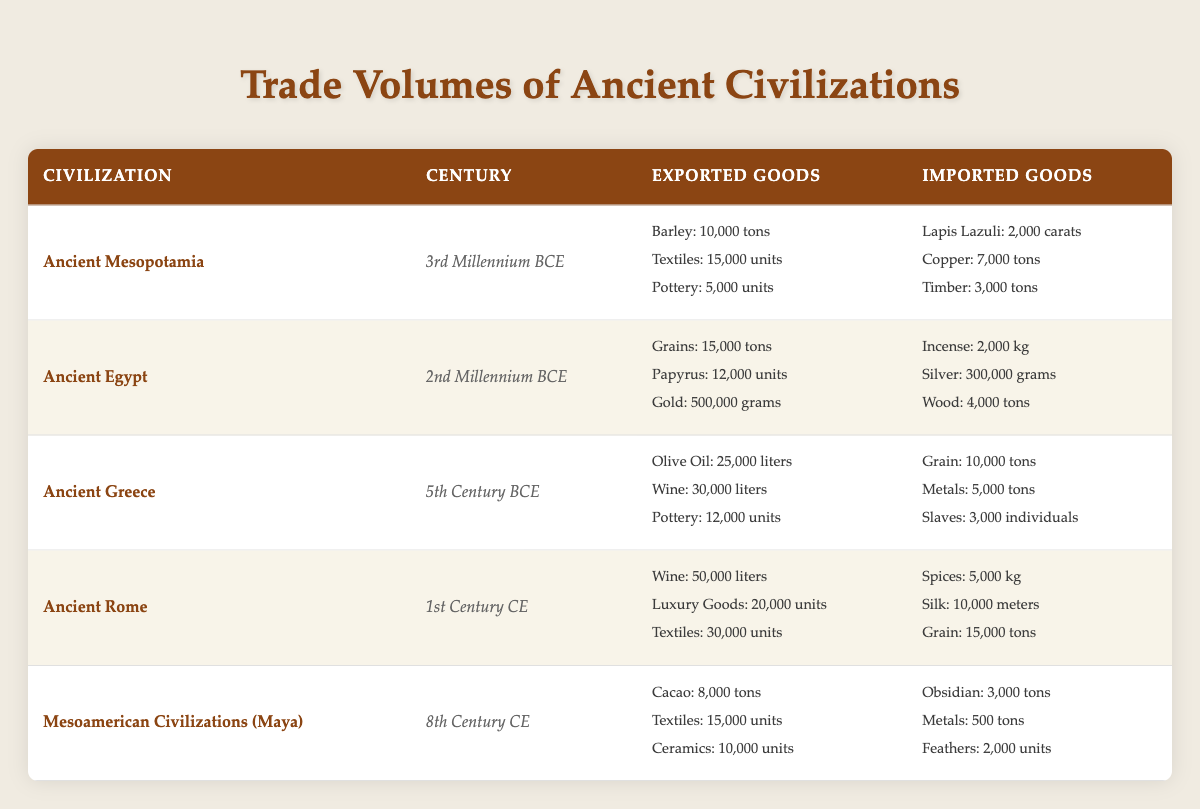What civilization exported the most quantities of textiles? According to the table, Ancient Rome exported 30,000 units of textiles, which is the highest compared to other civilizations listed.
Answer: Ancient Rome How many tons of barley did Ancient Mesopotamia export? The table states that Ancient Mesopotamia exported 10,000 tons of barley as per the recorded data.
Answer: 10,000 tons Did Ancient Egypt import more incense than silver? The table shows that Ancient Egypt imported 2,000 kg of incense and 300,000 grams of silver. Since 2,000 kg equals 2,000,000 grams, Ancient Egypt imported more incense than silver.
Answer: Yes What is the total amount of cacao and textiles exported by Mesoamerican civilizations? The table indicates that Mesoamerican civilizations exported 8,000 tons of cacao and 15,000 units of textiles. Adding these quantities together gives a total of 8,000 and 15,000 without a direct unit for the mixture since they are different goods, but the total number of goods, which is 8,000 + 15,000 = 23,000 units of goods exported.
Answer: 23,000 units Which civilization imported the least amount of metals in tons? From the table, Mesoamerican civilizations imported only 500 tons of metals, which is the lowest quantity compared to Ancient Greece (5,000 tons), Ancient Rome (metric conversion needed but higher than 500), and Ancient Mesopotamia's 7,000 tons.
Answer: Mesoamerican Civilizations (Maya) How many units of pottery did Ancient Greece export? The table indicates that Ancient Greece exported 12,000 units of pottery.
Answer: 12,000 units What is the difference in the quantity of wine exported by Ancient Rome compared to Ancient Greece? The table states that Ancient Rome exported 50,000 liters of wine while Ancient Greece exported 30,000 liters. The difference is calculated by subtracting 30,000 from 50,000, which gives us 20,000 liters.
Answer: 20,000 liters Did Ancient Mesopotamia import more timber than Ancient Egypt imported wood? Ancient Mesopotamia imported 3,000 tons of timber while Ancient Egypt imported 4,000 tons of wood. Since 4,000 tons is greater than 3,000 tons, Ancient Mesopotamia did not import more timber than Ancient Egypt's imported wood.
Answer: No 